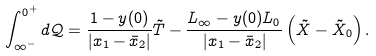Convert formula to latex. <formula><loc_0><loc_0><loc_500><loc_500>\int _ { \infty ^ { - } } ^ { 0 ^ { + } } d \mathcal { Q } = \frac { 1 - y ( 0 ) } { | x _ { 1 } - \bar { x } _ { 2 } | } \tilde { T } - \frac { L _ { \infty } - y ( 0 ) L _ { 0 } } { | x _ { 1 } - \bar { x } _ { 2 } | } \left ( \tilde { X } - \tilde { X } _ { 0 } \right ) .</formula> 